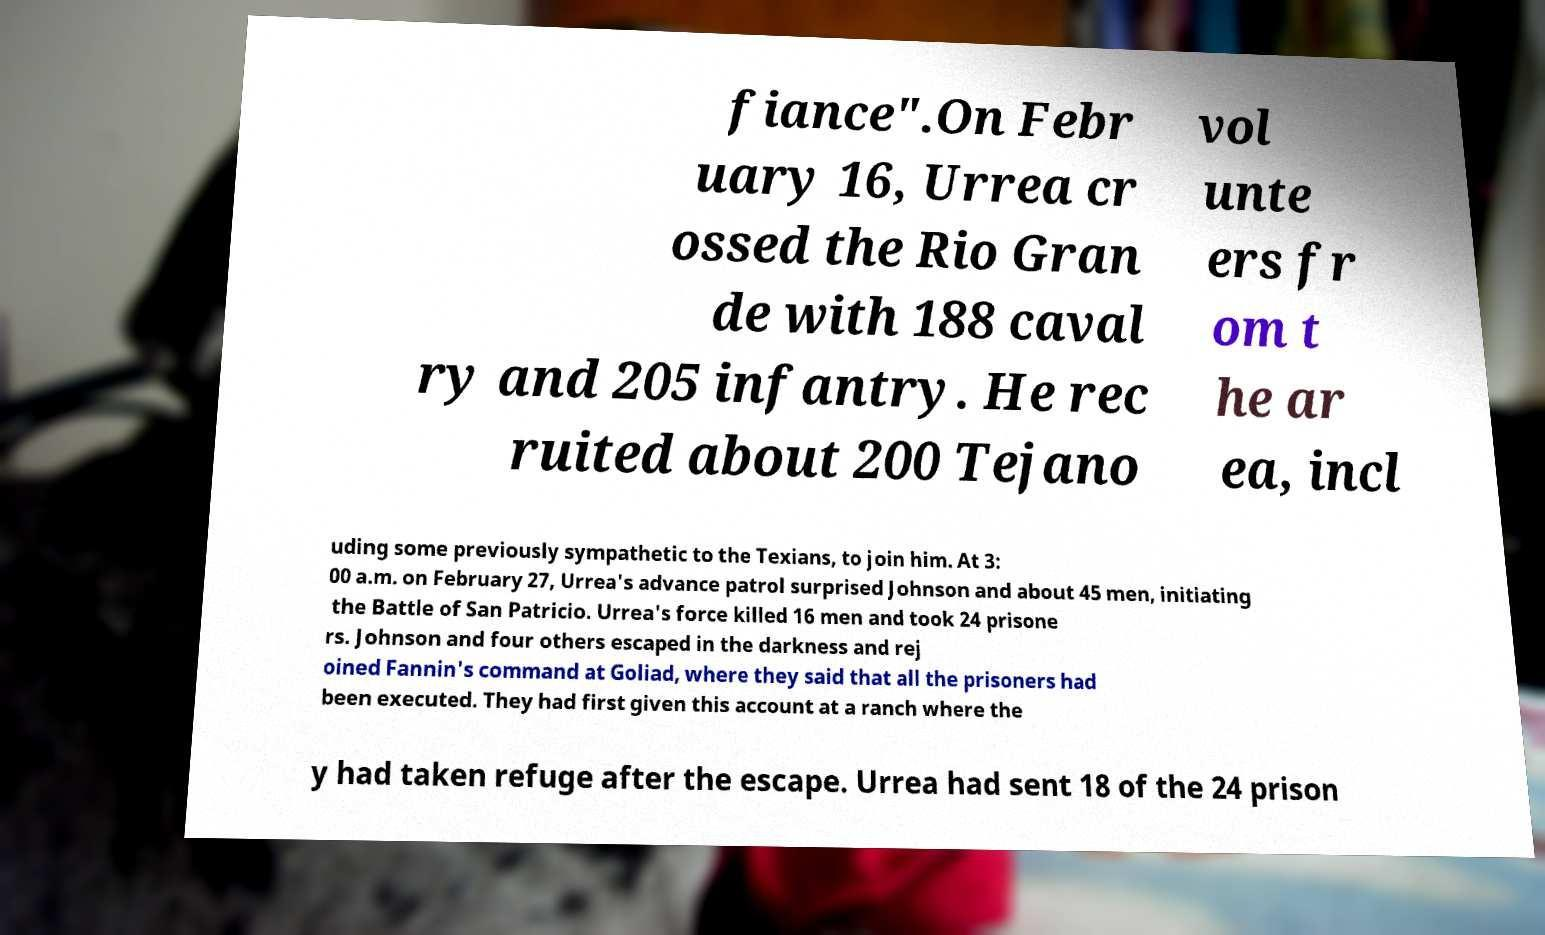There's text embedded in this image that I need extracted. Can you transcribe it verbatim? fiance".On Febr uary 16, Urrea cr ossed the Rio Gran de with 188 caval ry and 205 infantry. He rec ruited about 200 Tejano vol unte ers fr om t he ar ea, incl uding some previously sympathetic to the Texians, to join him. At 3: 00 a.m. on February 27, Urrea's advance patrol surprised Johnson and about 45 men, initiating the Battle of San Patricio. Urrea's force killed 16 men and took 24 prisone rs. Johnson and four others escaped in the darkness and rej oined Fannin's command at Goliad, where they said that all the prisoners had been executed. They had first given this account at a ranch where the y had taken refuge after the escape. Urrea had sent 18 of the 24 prison 